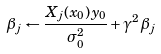Convert formula to latex. <formula><loc_0><loc_0><loc_500><loc_500>\beta _ { j } \leftarrow \frac { X _ { j } ( x _ { 0 } ) y _ { 0 } } { \sigma _ { 0 } ^ { 2 } } + \gamma ^ { 2 } \beta _ { j }</formula> 